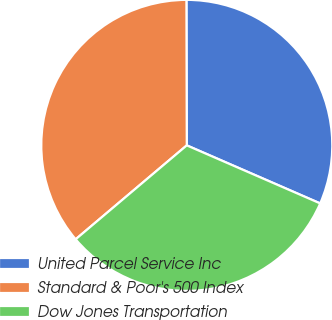<chart> <loc_0><loc_0><loc_500><loc_500><pie_chart><fcel>United Parcel Service Inc<fcel>Standard & Poor's 500 Index<fcel>Dow Jones Transportation<nl><fcel>31.57%<fcel>36.13%<fcel>32.3%<nl></chart> 